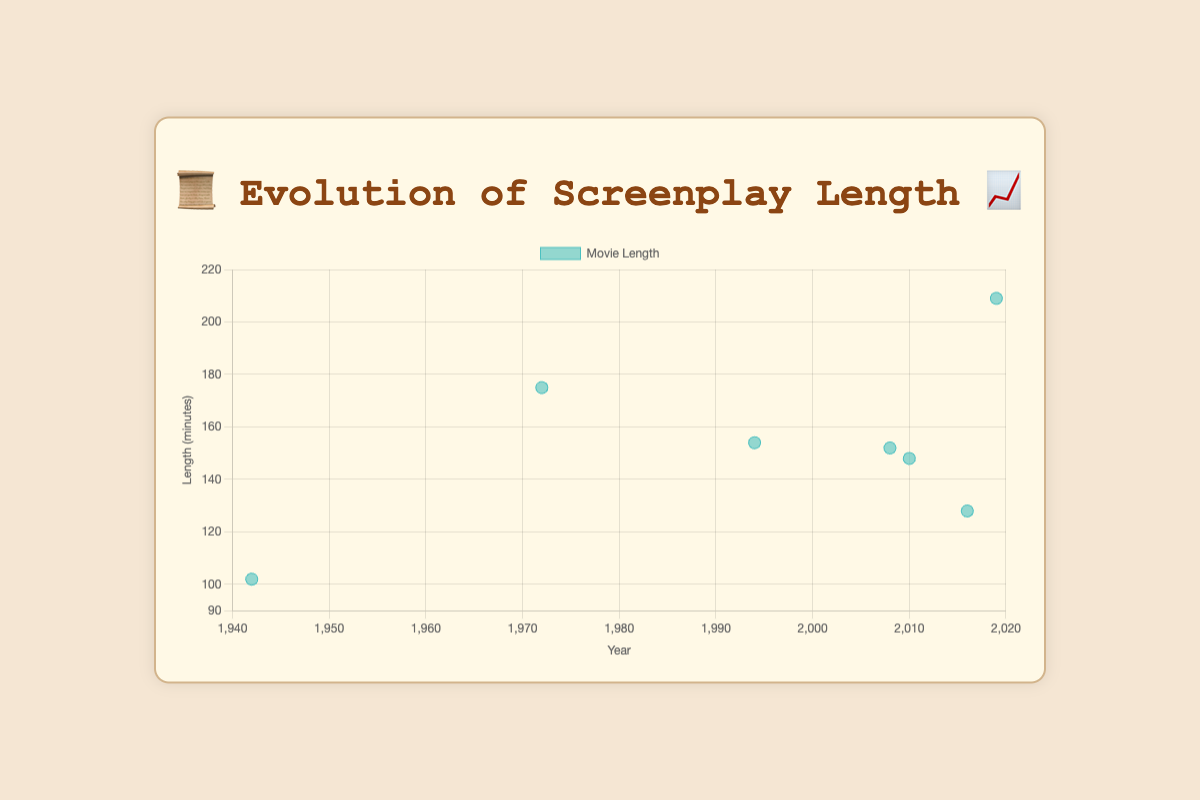What is the average screenplay length in the Digital Age 💻, according to the figure? The Digital Age 💻 spans from 2010 onwards. The movies listed are "Inception" (148 mins), "La La Land" (128 mins), and "The Irishman" (209 mins). Their total length is 148 + 128 + 209 = 485 minutes. Dividing by the 3 movies, the average length is 485 / 3 = 161.67 minutes
Answer: 161.67 minutes Which era has the highest movie length in the dataset? The highest length in the dataset is "The Irishman" with 209 minutes, which falls in the Digital Age 💻. No other era has a higher length.
Answer: Digital Age 💻 What is the difference in screenplay length between "The Godfather" and "Casablanca"? "The Godfather" has a length of 175 minutes, while "Casablanca" has a length of 102 minutes. The difference is calculated as 175 - 102 = 73 minutes.
Answer: 73 minutes How many movies have a screenplay length greater than 150 minutes? The movies greater than 150 minutes in length are "The Godfather" (175 mins), "Pulp Fiction" (154 mins), "The Dark Knight" (152 mins), "Inception" (148 mins), and "The Irishman" (209 mins). There are 4 movies total > 150 mins.
Answer: 4 Which movie in the Blockbuster Era 🍿 has the highest screenplay length? In the Blockbuster Era 🍿, the dataset includes "Pulp Fiction" (154 mins) and "The Dark Knight" (152 mins). The highest length is 154 mins for "Pulp Fiction".
Answer: Pulp Fiction Between "The Godfather" and "The Irishman", which movie has the longer screenplay length and by how much? "The Godfather" has a length of 175 minutes, while "The Irishman" has 209 minutes. The difference is 209 - 175 = 34 minutes. "The Irishman" is longer by 34 minutes.
Answer: The Irishman, 34 minutes How did average screenplay lengths change from the Golden Age 🎭 to the New Hollywood 🎬 era? In the Golden Age 🎭, "Casablanca" is the only movie listed with 102 minutes. In the New Hollywood 🎬 era, only "The Godfather" is listed with 175 minutes. The change is 175 - 102 = 73 minutes, an increase of 73 minutes.
Answer: Increase of 73 minutes 